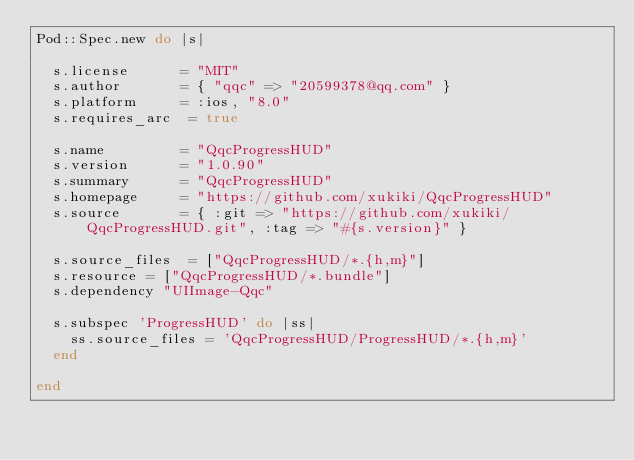Convert code to text. <code><loc_0><loc_0><loc_500><loc_500><_Ruby_>Pod::Spec.new do |s|

  s.license      = "MIT"
  s.author       = { "qqc" => "20599378@qq.com" }
  s.platform     = :ios, "8.0"
  s.requires_arc  = true

  s.name         = "QqcProgressHUD"
  s.version      = "1.0.90"
  s.summary      = "QqcProgressHUD"
  s.homepage     = "https://github.com/xukiki/QqcProgressHUD"
  s.source       = { :git => "https://github.com/xukiki/QqcProgressHUD.git", :tag => "#{s.version}" }
  
  s.source_files  = ["QqcProgressHUD/*.{h,m}"]
  s.resource = ["QqcProgressHUD/*.bundle"]
  s.dependency "UIImage-Qqc"
  
  s.subspec 'ProgressHUD' do |ss|
    ss.source_files = 'QqcProgressHUD/ProgressHUD/*.{h,m}'
  end

end
</code> 